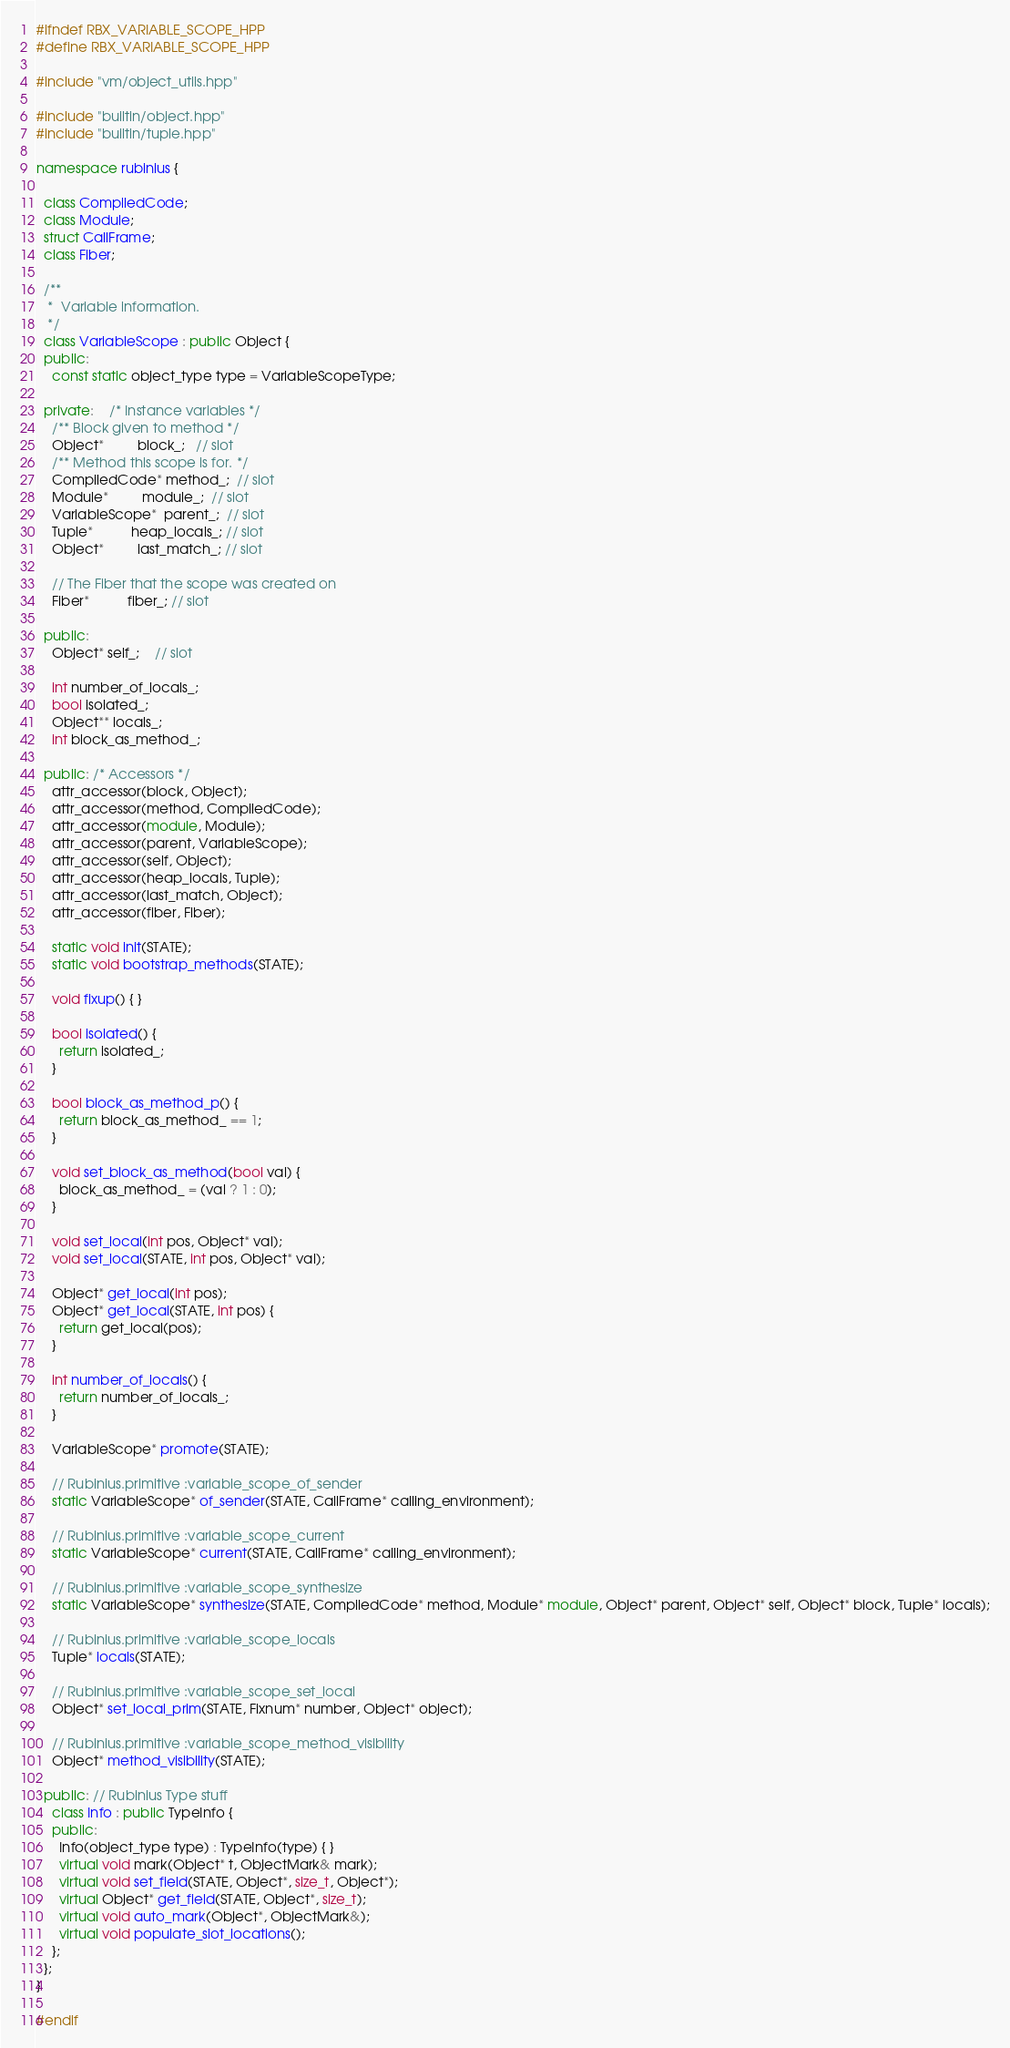Convert code to text. <code><loc_0><loc_0><loc_500><loc_500><_C++_>#ifndef RBX_VARIABLE_SCOPE_HPP
#define RBX_VARIABLE_SCOPE_HPP

#include "vm/object_utils.hpp"

#include "builtin/object.hpp"
#include "builtin/tuple.hpp"

namespace rubinius {

  class CompiledCode;
  class Module;
  struct CallFrame;
  class Fiber;

  /**
   *  Variable information.
   */
  class VariableScope : public Object {
  public:
    const static object_type type = VariableScopeType;

  private:    /* Instance variables */
    /** Block given to method */
    Object*         block_;   // slot
    /** Method this scope is for. */
    CompiledCode* method_;  // slot
    Module*         module_;  // slot
    VariableScope*  parent_;  // slot
    Tuple*          heap_locals_; // slot
    Object*         last_match_; // slot

    // The Fiber that the scope was created on
    Fiber*          fiber_; // slot

  public:
    Object* self_;    // slot

    int number_of_locals_;
    bool isolated_;
    Object** locals_;
    int block_as_method_;

  public: /* Accessors */
    attr_accessor(block, Object);
    attr_accessor(method, CompiledCode);
    attr_accessor(module, Module);
    attr_accessor(parent, VariableScope);
    attr_accessor(self, Object);
    attr_accessor(heap_locals, Tuple);
    attr_accessor(last_match, Object);
    attr_accessor(fiber, Fiber);

    static void init(STATE);
    static void bootstrap_methods(STATE);

    void fixup() { }

    bool isolated() {
      return isolated_;
    }

    bool block_as_method_p() {
      return block_as_method_ == 1;
    }

    void set_block_as_method(bool val) {
      block_as_method_ = (val ? 1 : 0);
    }

    void set_local(int pos, Object* val);
    void set_local(STATE, int pos, Object* val);

    Object* get_local(int pos);
    Object* get_local(STATE, int pos) {
      return get_local(pos);
    }

    int number_of_locals() {
      return number_of_locals_;
    }

    VariableScope* promote(STATE);

    // Rubinius.primitive :variable_scope_of_sender
    static VariableScope* of_sender(STATE, CallFrame* calling_environment);

    // Rubinius.primitive :variable_scope_current
    static VariableScope* current(STATE, CallFrame* calling_environment);

    // Rubinius.primitive :variable_scope_synthesize
    static VariableScope* synthesize(STATE, CompiledCode* method, Module* module, Object* parent, Object* self, Object* block, Tuple* locals);

    // Rubinius.primitive :variable_scope_locals
    Tuple* locals(STATE);

    // Rubinius.primitive :variable_scope_set_local
    Object* set_local_prim(STATE, Fixnum* number, Object* object);

    // Rubinius.primitive :variable_scope_method_visibility
    Object* method_visibility(STATE);

  public: // Rubinius Type stuff
    class Info : public TypeInfo {
    public:
      Info(object_type type) : TypeInfo(type) { }
      virtual void mark(Object* t, ObjectMark& mark);
      virtual void set_field(STATE, Object*, size_t, Object*);
      virtual Object* get_field(STATE, Object*, size_t);
      virtual void auto_mark(Object*, ObjectMark&);
      virtual void populate_slot_locations();
    };
  };
}

#endif
</code> 